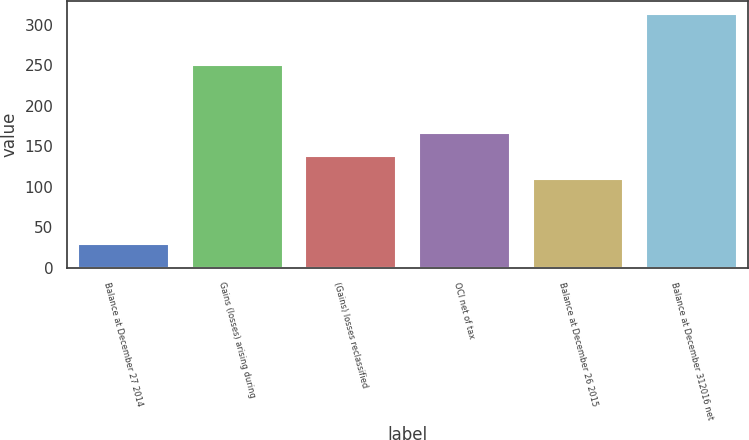Convert chart to OTSL. <chart><loc_0><loc_0><loc_500><loc_500><bar_chart><fcel>Balance at December 27 2014<fcel>Gains (losses) arising during<fcel>(Gains) losses reclassified<fcel>OCI net of tax<fcel>Balance at December 26 2015<fcel>Balance at December 312016 net<nl><fcel>29<fcel>250<fcel>137.4<fcel>165.8<fcel>109<fcel>313<nl></chart> 